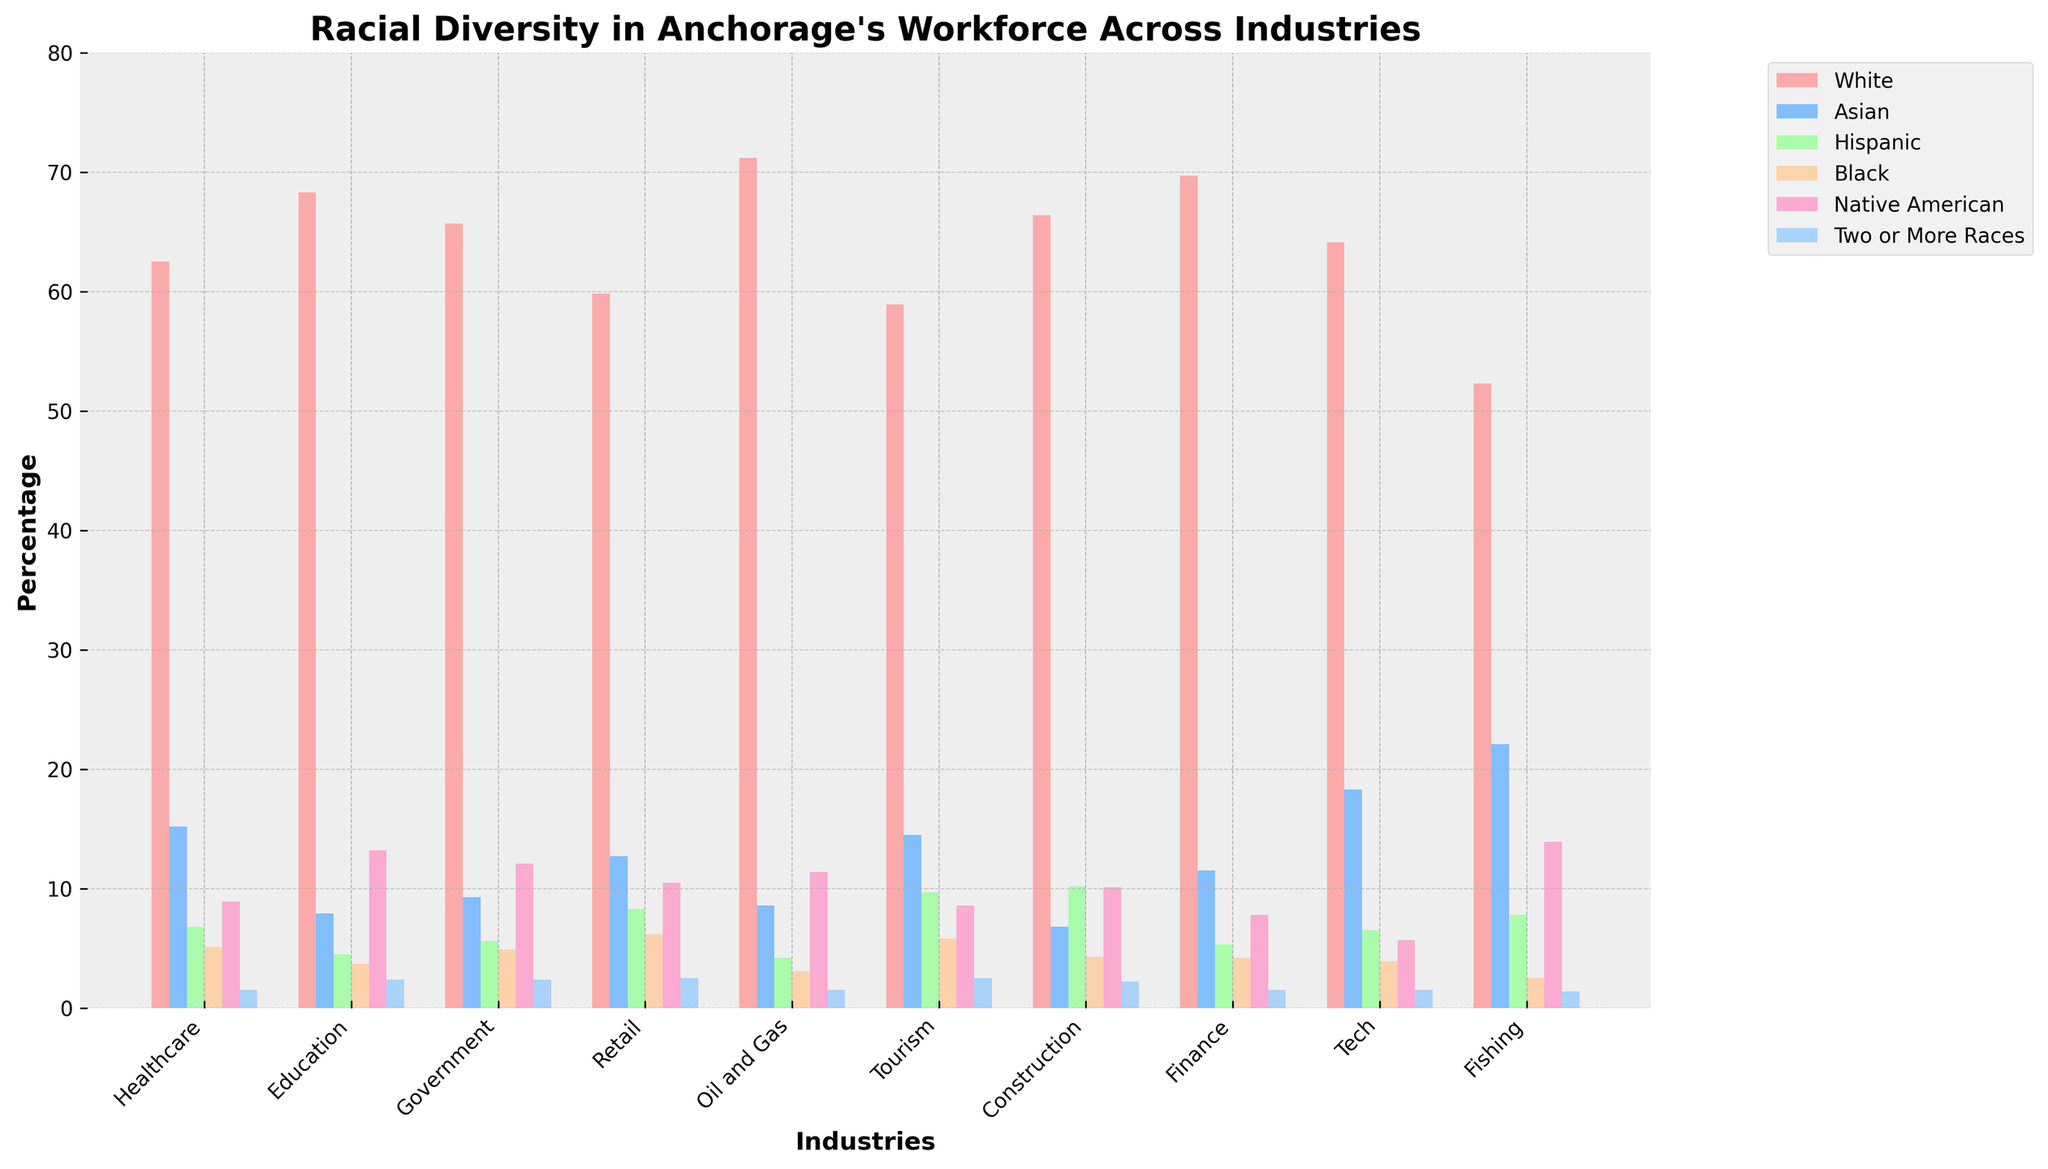What's the industry with the highest percentage of Asian employees? Look at the bars colored in blue and compare their heights across different industries. The industry with the highest blue bar represents the highest percentage of Asian employees. For Fishing, the height is the tallest among all.
Answer: Fishing Which industry has the most balanced racial diversity? A balanced racial diversity should have bars of relatively equal height across all racial categories. The Healthcare industry shows diversity where no single racial category overwhelmingly dominates others compared to other industries.
Answer: Healthcare What is the sum of the Hispanic workforce percentages in Healthcare and Retail combined? Find the bars representing Hispanics in Healthcare and Retail, which are orange. Add their values: 6.8 (Healthcare) + 8.3 (Retail) = 15.1.
Answer: 15.1 Which industry has a lower percentage of Native American employees: Tech or Finance? Compare the height of the green bars representing Native American employees for Tech and Finance. Tech has a value of 5.7%, and Finance has a value of 7.8%.
Answer: Tech How does the percentage of Black employees in Government compare to those in Construction? Compare the purple bars representing Black employees in both Government and Construction. Government has a height of 4.9%, whereas Construction has a height of 4.3%, meaning Government has a higher percentage.
Answer: Government What is the average percentage of White employees across all industries? Sum the percentages of White employees in all industries and divide by the number of industries: (62.5 + 68.3 + 65.7 + 59.8 + 71.2 + 58.9 + 66.4 + 69.7 + 64.1 + 52.3) / 10 = 63.89.
Answer: 63.89 In which industry is the percentage of Two or More Races the highest? Compare the heights of the yellow bars representing Two or More Races across all industries. The highest is found in Retail, with a value of 2.5%.
Answer: Retail Which industry shows the least racial diversity in terms of the largest gap between the highest and lowest percentages? The least diverse industry has the largest difference between the highest and lowest bars. Oil and Gas shows the largest gap with the highest being White (71.2%) and the lowest Two or More Races (1.5%) giving a gap of 69.7%.
Answer: Oil and Gas What's the difference in the percentage of Asian employees between the Tech and Education industries? Subtract the percentage of Asian employees in Education from that in Tech: 18.3% (Tech) - 7.9% (Education) = 10.4%.
Answer: 10.4 Which industry has a similar percentage of Native American and Two or More Races employees? Look for an industry where the green and yellow bars are close in height. Retail and Tourism have similar percentages for these categories (Retail: 10.5% Native American, 2.5% Two or More Races; Tourism: 8.6% Native American, 2.5% Two or More Races). Choose any of these.
Answer: Tourism 